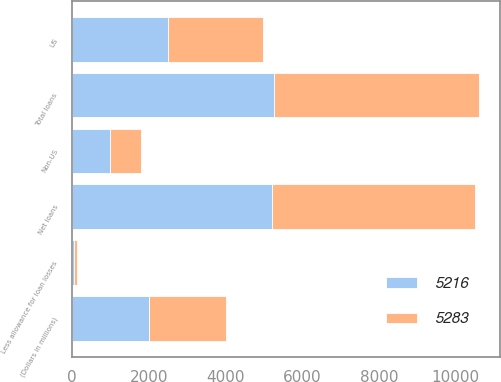Convert chart. <chart><loc_0><loc_0><loc_500><loc_500><stacked_bar_chart><ecel><fcel>(Dollars in millions)<fcel>US<fcel>Non-US<fcel>Total loans<fcel>Less allowance for loan losses<fcel>Net loans<nl><fcel>5283<fcel>2001<fcel>2479<fcel>810<fcel>5341<fcel>58<fcel>5283<nl><fcel>5216<fcel>2000<fcel>2502<fcel>974<fcel>5273<fcel>57<fcel>5216<nl></chart> 